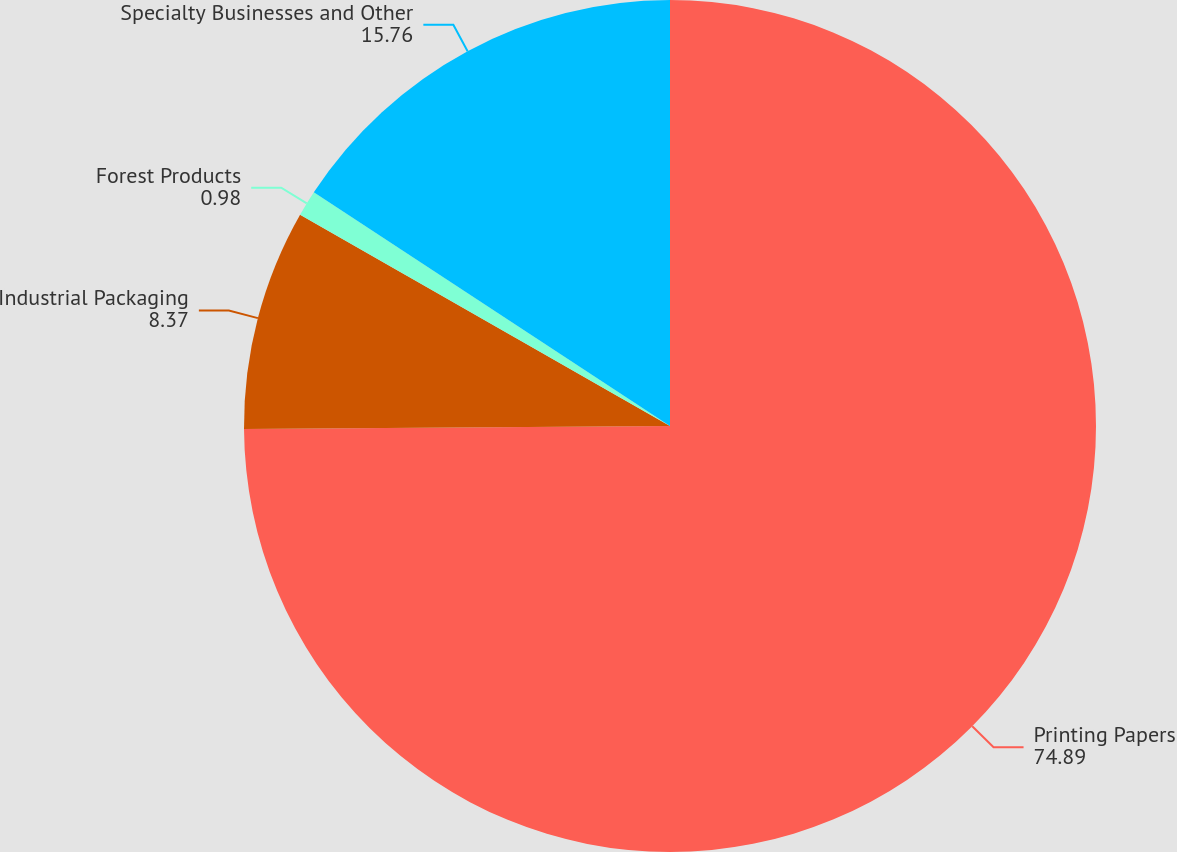Convert chart to OTSL. <chart><loc_0><loc_0><loc_500><loc_500><pie_chart><fcel>Printing Papers<fcel>Industrial Packaging<fcel>Forest Products<fcel>Specialty Businesses and Other<nl><fcel>74.89%<fcel>8.37%<fcel>0.98%<fcel>15.76%<nl></chart> 